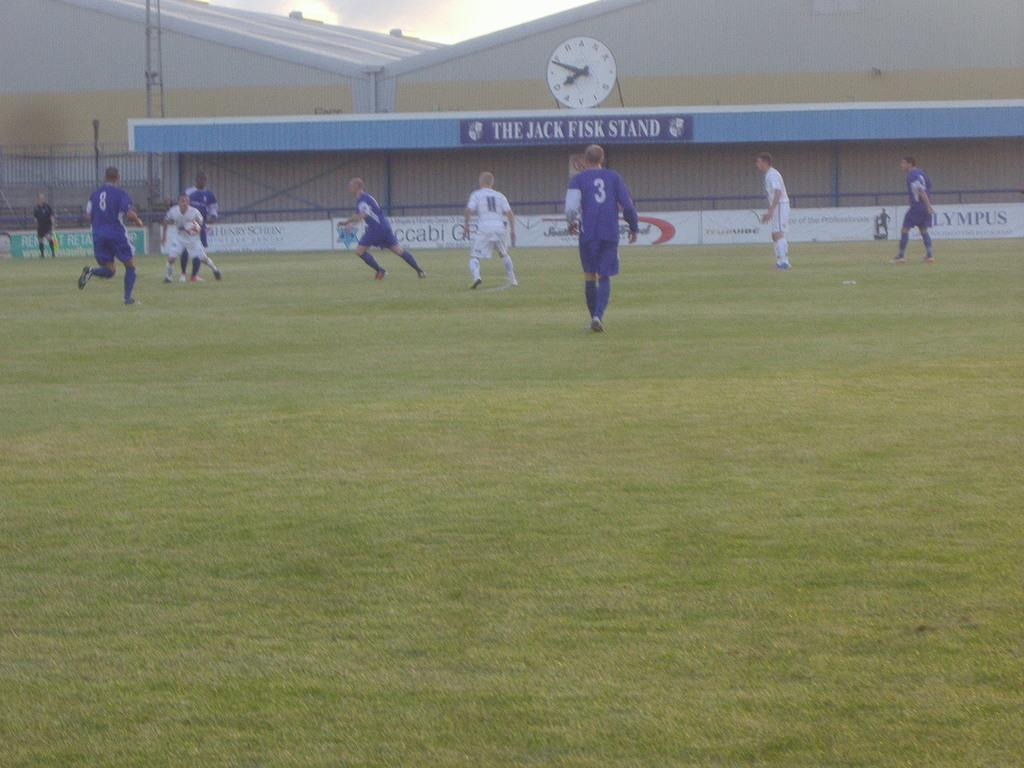<image>
Render a clear and concise summary of the photo. A sports field with a sign visible reading The Jack Fish Stand. 